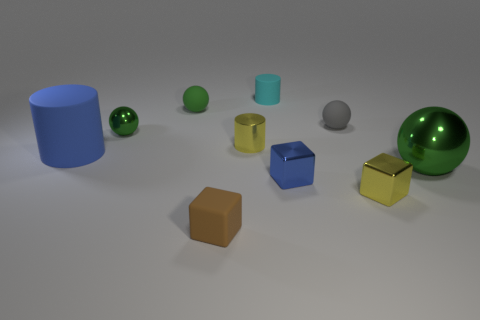How many green spheres must be subtracted to get 1 green spheres? 2 Subtract all blue cylinders. How many green balls are left? 3 Subtract all blocks. How many objects are left? 7 Add 5 small shiny cubes. How many small shiny cubes exist? 7 Subtract 1 cyan cylinders. How many objects are left? 9 Subtract all big purple shiny objects. Subtract all tiny shiny objects. How many objects are left? 6 Add 1 tiny cyan rubber cylinders. How many tiny cyan rubber cylinders are left? 2 